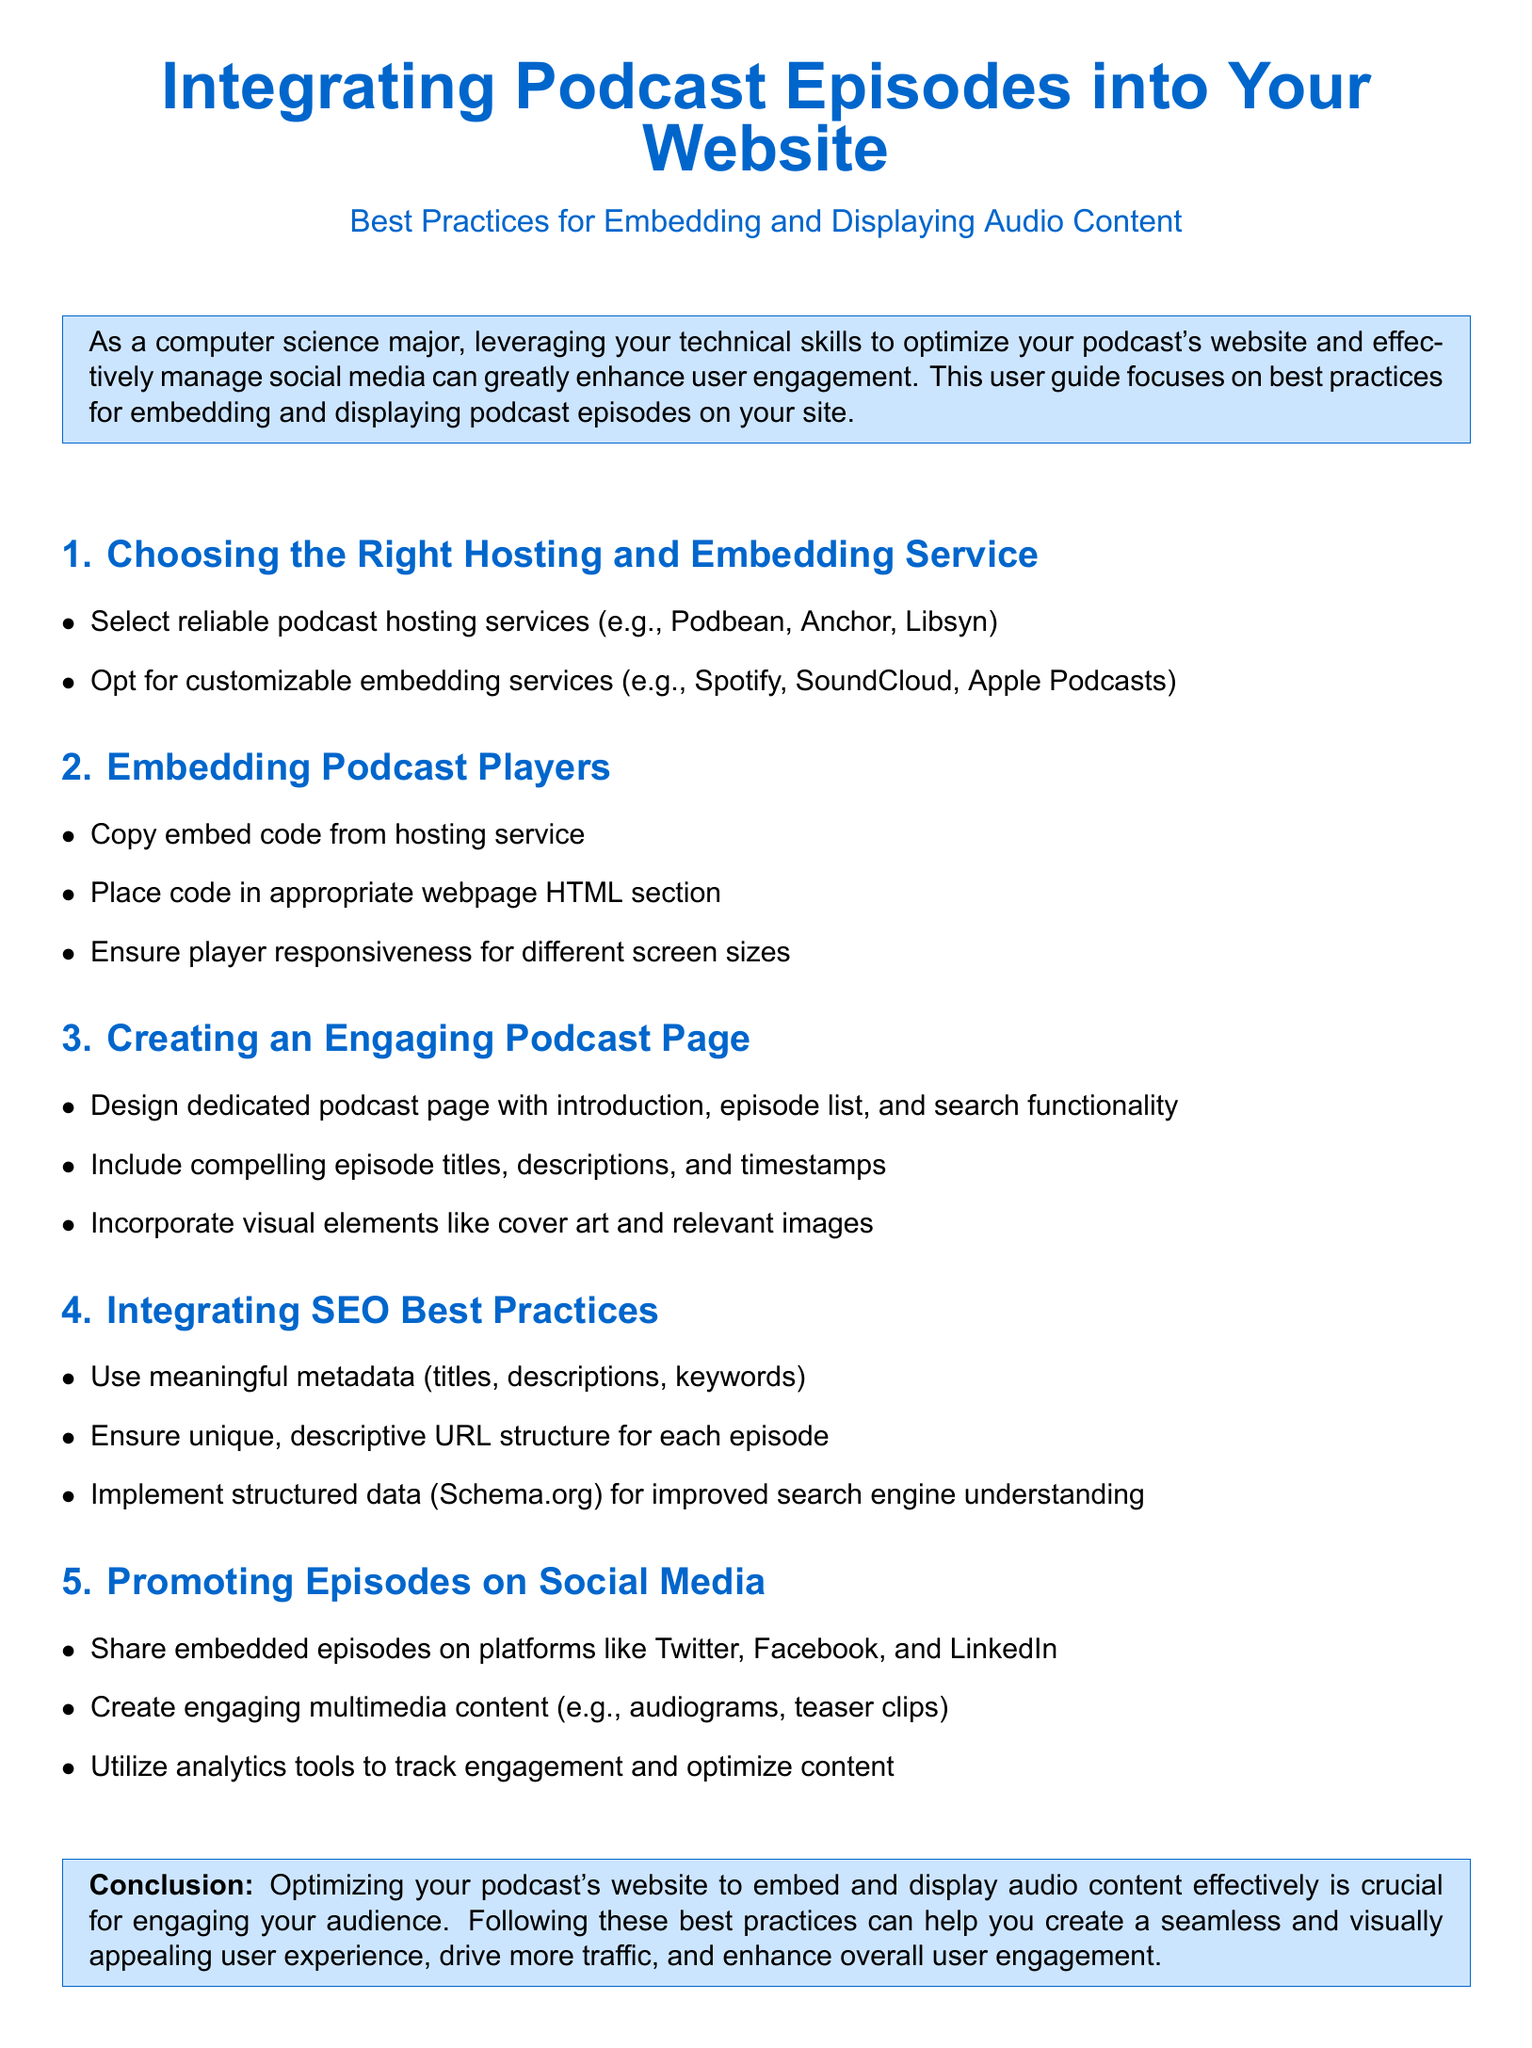what are the recommended hosting services? The document lists reliable podcast hosting services as Podbean, Anchor, and Libsyn.
Answer: Podbean, Anchor, Libsyn what is essential for player responsiveness? The document states that it's essential to ensure player responsiveness for different screen sizes when embedding podcast players.
Answer: different screen sizes what content should a dedicated podcast page include? The guide suggests including an introduction, episode list, and search functionality on a dedicated podcast page.
Answer: introduction, episode list, and search functionality what metadata should be used for SEO? The document emphasizes using meaningful metadata such as titles, descriptions, and keywords for SEO best practices.
Answer: titles, descriptions, keywords which platforms should episodes be shared on? The guide recommends sharing embedded episodes on Twitter, Facebook, and LinkedIn.
Answer: Twitter, Facebook, LinkedIn what structured data is suggested for improved SEO? The document suggests implementing structured data from Schema.org for better search engine understanding.
Answer: Schema.org how can engagement be tracked on social media? The guide mentions utilizing analytics tools to track engagement and optimize content.
Answer: analytics tools what is the primary aim of optimizing the podcast's website? According to the conclusion, the primary aim is to create a seamless and visually appealing user experience that drives traffic.
Answer: seamless and visually appealing user experience 